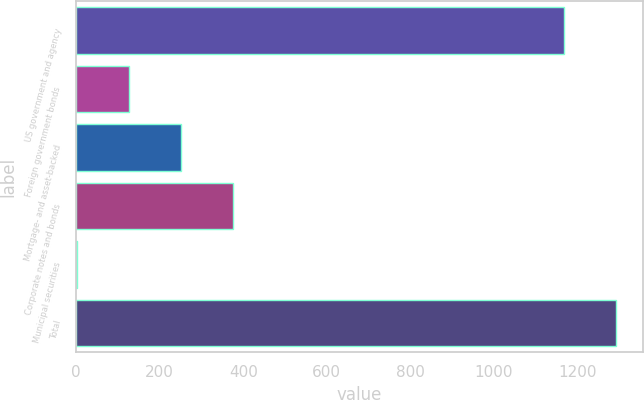<chart> <loc_0><loc_0><loc_500><loc_500><bar_chart><fcel>US government and agency<fcel>Foreign government bonds<fcel>Mortgage- and asset-backed<fcel>Corporate notes and bonds<fcel>Municipal securities<fcel>Total<nl><fcel>1167<fcel>125.6<fcel>250.2<fcel>374.8<fcel>1<fcel>1291.6<nl></chart> 